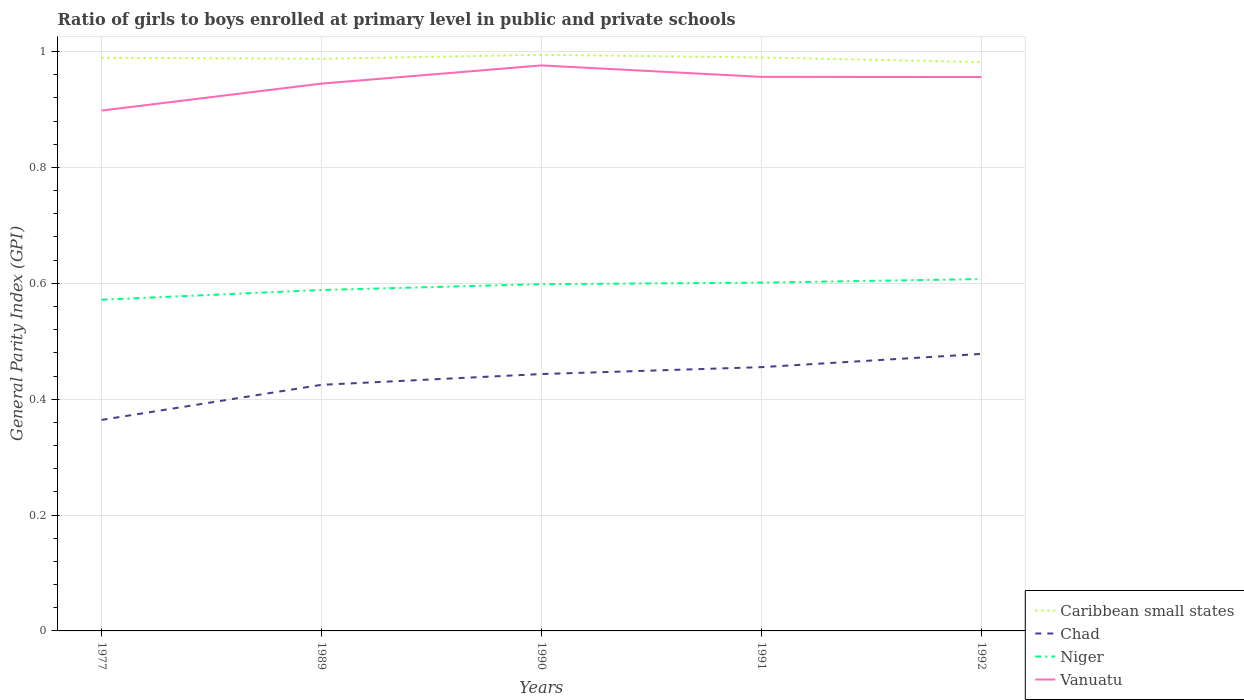Does the line corresponding to Niger intersect with the line corresponding to Chad?
Your answer should be compact. No. Across all years, what is the maximum general parity index in Caribbean small states?
Your answer should be very brief. 0.98. What is the total general parity index in Vanuatu in the graph?
Provide a short and direct response. -0.08. What is the difference between the highest and the second highest general parity index in Chad?
Provide a short and direct response. 0.11. What is the difference between the highest and the lowest general parity index in Chad?
Offer a terse response. 3. Is the general parity index in Niger strictly greater than the general parity index in Vanuatu over the years?
Offer a very short reply. Yes. How many years are there in the graph?
Make the answer very short. 5. Does the graph contain any zero values?
Make the answer very short. No. How many legend labels are there?
Your answer should be very brief. 4. How are the legend labels stacked?
Your response must be concise. Vertical. What is the title of the graph?
Your answer should be very brief. Ratio of girls to boys enrolled at primary level in public and private schools. Does "West Bank and Gaza" appear as one of the legend labels in the graph?
Keep it short and to the point. No. What is the label or title of the X-axis?
Your response must be concise. Years. What is the label or title of the Y-axis?
Your answer should be compact. General Parity Index (GPI). What is the General Parity Index (GPI) in Caribbean small states in 1977?
Your response must be concise. 0.99. What is the General Parity Index (GPI) of Chad in 1977?
Provide a succinct answer. 0.36. What is the General Parity Index (GPI) in Niger in 1977?
Your answer should be compact. 0.57. What is the General Parity Index (GPI) in Vanuatu in 1977?
Offer a very short reply. 0.9. What is the General Parity Index (GPI) of Caribbean small states in 1989?
Provide a short and direct response. 0.99. What is the General Parity Index (GPI) of Chad in 1989?
Your answer should be very brief. 0.42. What is the General Parity Index (GPI) of Niger in 1989?
Make the answer very short. 0.59. What is the General Parity Index (GPI) of Vanuatu in 1989?
Give a very brief answer. 0.94. What is the General Parity Index (GPI) of Caribbean small states in 1990?
Give a very brief answer. 0.99. What is the General Parity Index (GPI) in Chad in 1990?
Your answer should be compact. 0.44. What is the General Parity Index (GPI) in Niger in 1990?
Provide a short and direct response. 0.6. What is the General Parity Index (GPI) in Vanuatu in 1990?
Offer a very short reply. 0.98. What is the General Parity Index (GPI) of Caribbean small states in 1991?
Provide a short and direct response. 0.99. What is the General Parity Index (GPI) of Chad in 1991?
Give a very brief answer. 0.46. What is the General Parity Index (GPI) of Niger in 1991?
Provide a succinct answer. 0.6. What is the General Parity Index (GPI) of Vanuatu in 1991?
Provide a succinct answer. 0.96. What is the General Parity Index (GPI) in Caribbean small states in 1992?
Give a very brief answer. 0.98. What is the General Parity Index (GPI) of Chad in 1992?
Provide a succinct answer. 0.48. What is the General Parity Index (GPI) of Niger in 1992?
Provide a short and direct response. 0.61. What is the General Parity Index (GPI) in Vanuatu in 1992?
Ensure brevity in your answer.  0.96. Across all years, what is the maximum General Parity Index (GPI) in Caribbean small states?
Keep it short and to the point. 0.99. Across all years, what is the maximum General Parity Index (GPI) of Chad?
Give a very brief answer. 0.48. Across all years, what is the maximum General Parity Index (GPI) of Niger?
Your answer should be compact. 0.61. Across all years, what is the maximum General Parity Index (GPI) in Vanuatu?
Your answer should be very brief. 0.98. Across all years, what is the minimum General Parity Index (GPI) of Caribbean small states?
Offer a very short reply. 0.98. Across all years, what is the minimum General Parity Index (GPI) of Chad?
Offer a very short reply. 0.36. Across all years, what is the minimum General Parity Index (GPI) in Niger?
Provide a short and direct response. 0.57. Across all years, what is the minimum General Parity Index (GPI) of Vanuatu?
Give a very brief answer. 0.9. What is the total General Parity Index (GPI) in Caribbean small states in the graph?
Your answer should be very brief. 4.94. What is the total General Parity Index (GPI) in Chad in the graph?
Offer a very short reply. 2.17. What is the total General Parity Index (GPI) of Niger in the graph?
Provide a short and direct response. 2.97. What is the total General Parity Index (GPI) of Vanuatu in the graph?
Give a very brief answer. 4.73. What is the difference between the General Parity Index (GPI) in Caribbean small states in 1977 and that in 1989?
Ensure brevity in your answer.  0. What is the difference between the General Parity Index (GPI) in Chad in 1977 and that in 1989?
Give a very brief answer. -0.06. What is the difference between the General Parity Index (GPI) of Niger in 1977 and that in 1989?
Provide a short and direct response. -0.02. What is the difference between the General Parity Index (GPI) in Vanuatu in 1977 and that in 1989?
Ensure brevity in your answer.  -0.05. What is the difference between the General Parity Index (GPI) of Caribbean small states in 1977 and that in 1990?
Ensure brevity in your answer.  -0.01. What is the difference between the General Parity Index (GPI) in Chad in 1977 and that in 1990?
Your answer should be compact. -0.08. What is the difference between the General Parity Index (GPI) in Niger in 1977 and that in 1990?
Keep it short and to the point. -0.03. What is the difference between the General Parity Index (GPI) of Vanuatu in 1977 and that in 1990?
Make the answer very short. -0.08. What is the difference between the General Parity Index (GPI) in Caribbean small states in 1977 and that in 1991?
Keep it short and to the point. -0. What is the difference between the General Parity Index (GPI) in Chad in 1977 and that in 1991?
Provide a short and direct response. -0.09. What is the difference between the General Parity Index (GPI) of Niger in 1977 and that in 1991?
Offer a very short reply. -0.03. What is the difference between the General Parity Index (GPI) in Vanuatu in 1977 and that in 1991?
Offer a very short reply. -0.06. What is the difference between the General Parity Index (GPI) in Caribbean small states in 1977 and that in 1992?
Provide a short and direct response. 0.01. What is the difference between the General Parity Index (GPI) of Chad in 1977 and that in 1992?
Offer a terse response. -0.11. What is the difference between the General Parity Index (GPI) in Niger in 1977 and that in 1992?
Your response must be concise. -0.04. What is the difference between the General Parity Index (GPI) of Vanuatu in 1977 and that in 1992?
Make the answer very short. -0.06. What is the difference between the General Parity Index (GPI) of Caribbean small states in 1989 and that in 1990?
Make the answer very short. -0.01. What is the difference between the General Parity Index (GPI) of Chad in 1989 and that in 1990?
Provide a short and direct response. -0.02. What is the difference between the General Parity Index (GPI) of Niger in 1989 and that in 1990?
Provide a succinct answer. -0.01. What is the difference between the General Parity Index (GPI) in Vanuatu in 1989 and that in 1990?
Offer a terse response. -0.03. What is the difference between the General Parity Index (GPI) of Caribbean small states in 1989 and that in 1991?
Offer a very short reply. -0. What is the difference between the General Parity Index (GPI) of Chad in 1989 and that in 1991?
Give a very brief answer. -0.03. What is the difference between the General Parity Index (GPI) of Niger in 1989 and that in 1991?
Offer a very short reply. -0.01. What is the difference between the General Parity Index (GPI) of Vanuatu in 1989 and that in 1991?
Keep it short and to the point. -0.01. What is the difference between the General Parity Index (GPI) in Caribbean small states in 1989 and that in 1992?
Your answer should be compact. 0.01. What is the difference between the General Parity Index (GPI) of Chad in 1989 and that in 1992?
Offer a very short reply. -0.05. What is the difference between the General Parity Index (GPI) in Niger in 1989 and that in 1992?
Give a very brief answer. -0.02. What is the difference between the General Parity Index (GPI) in Vanuatu in 1989 and that in 1992?
Your response must be concise. -0.01. What is the difference between the General Parity Index (GPI) of Caribbean small states in 1990 and that in 1991?
Give a very brief answer. 0. What is the difference between the General Parity Index (GPI) of Chad in 1990 and that in 1991?
Provide a short and direct response. -0.01. What is the difference between the General Parity Index (GPI) of Niger in 1990 and that in 1991?
Offer a very short reply. -0. What is the difference between the General Parity Index (GPI) in Vanuatu in 1990 and that in 1991?
Ensure brevity in your answer.  0.02. What is the difference between the General Parity Index (GPI) of Caribbean small states in 1990 and that in 1992?
Offer a terse response. 0.01. What is the difference between the General Parity Index (GPI) of Chad in 1990 and that in 1992?
Make the answer very short. -0.03. What is the difference between the General Parity Index (GPI) in Niger in 1990 and that in 1992?
Make the answer very short. -0.01. What is the difference between the General Parity Index (GPI) of Vanuatu in 1990 and that in 1992?
Offer a very short reply. 0.02. What is the difference between the General Parity Index (GPI) in Caribbean small states in 1991 and that in 1992?
Your response must be concise. 0.01. What is the difference between the General Parity Index (GPI) in Chad in 1991 and that in 1992?
Give a very brief answer. -0.02. What is the difference between the General Parity Index (GPI) of Niger in 1991 and that in 1992?
Offer a very short reply. -0.01. What is the difference between the General Parity Index (GPI) of Caribbean small states in 1977 and the General Parity Index (GPI) of Chad in 1989?
Give a very brief answer. 0.56. What is the difference between the General Parity Index (GPI) in Caribbean small states in 1977 and the General Parity Index (GPI) in Niger in 1989?
Offer a very short reply. 0.4. What is the difference between the General Parity Index (GPI) of Caribbean small states in 1977 and the General Parity Index (GPI) of Vanuatu in 1989?
Your answer should be very brief. 0.04. What is the difference between the General Parity Index (GPI) in Chad in 1977 and the General Parity Index (GPI) in Niger in 1989?
Ensure brevity in your answer.  -0.22. What is the difference between the General Parity Index (GPI) in Chad in 1977 and the General Parity Index (GPI) in Vanuatu in 1989?
Give a very brief answer. -0.58. What is the difference between the General Parity Index (GPI) in Niger in 1977 and the General Parity Index (GPI) in Vanuatu in 1989?
Offer a very short reply. -0.37. What is the difference between the General Parity Index (GPI) in Caribbean small states in 1977 and the General Parity Index (GPI) in Chad in 1990?
Ensure brevity in your answer.  0.55. What is the difference between the General Parity Index (GPI) in Caribbean small states in 1977 and the General Parity Index (GPI) in Niger in 1990?
Your answer should be compact. 0.39. What is the difference between the General Parity Index (GPI) in Caribbean small states in 1977 and the General Parity Index (GPI) in Vanuatu in 1990?
Your response must be concise. 0.01. What is the difference between the General Parity Index (GPI) in Chad in 1977 and the General Parity Index (GPI) in Niger in 1990?
Your answer should be compact. -0.23. What is the difference between the General Parity Index (GPI) of Chad in 1977 and the General Parity Index (GPI) of Vanuatu in 1990?
Your response must be concise. -0.61. What is the difference between the General Parity Index (GPI) in Niger in 1977 and the General Parity Index (GPI) in Vanuatu in 1990?
Your answer should be very brief. -0.4. What is the difference between the General Parity Index (GPI) of Caribbean small states in 1977 and the General Parity Index (GPI) of Chad in 1991?
Ensure brevity in your answer.  0.53. What is the difference between the General Parity Index (GPI) in Caribbean small states in 1977 and the General Parity Index (GPI) in Niger in 1991?
Keep it short and to the point. 0.39. What is the difference between the General Parity Index (GPI) in Caribbean small states in 1977 and the General Parity Index (GPI) in Vanuatu in 1991?
Offer a terse response. 0.03. What is the difference between the General Parity Index (GPI) in Chad in 1977 and the General Parity Index (GPI) in Niger in 1991?
Make the answer very short. -0.24. What is the difference between the General Parity Index (GPI) of Chad in 1977 and the General Parity Index (GPI) of Vanuatu in 1991?
Your response must be concise. -0.59. What is the difference between the General Parity Index (GPI) in Niger in 1977 and the General Parity Index (GPI) in Vanuatu in 1991?
Offer a terse response. -0.38. What is the difference between the General Parity Index (GPI) of Caribbean small states in 1977 and the General Parity Index (GPI) of Chad in 1992?
Offer a terse response. 0.51. What is the difference between the General Parity Index (GPI) in Caribbean small states in 1977 and the General Parity Index (GPI) in Niger in 1992?
Provide a succinct answer. 0.38. What is the difference between the General Parity Index (GPI) of Chad in 1977 and the General Parity Index (GPI) of Niger in 1992?
Provide a succinct answer. -0.24. What is the difference between the General Parity Index (GPI) in Chad in 1977 and the General Parity Index (GPI) in Vanuatu in 1992?
Offer a very short reply. -0.59. What is the difference between the General Parity Index (GPI) in Niger in 1977 and the General Parity Index (GPI) in Vanuatu in 1992?
Ensure brevity in your answer.  -0.38. What is the difference between the General Parity Index (GPI) of Caribbean small states in 1989 and the General Parity Index (GPI) of Chad in 1990?
Offer a very short reply. 0.54. What is the difference between the General Parity Index (GPI) in Caribbean small states in 1989 and the General Parity Index (GPI) in Niger in 1990?
Make the answer very short. 0.39. What is the difference between the General Parity Index (GPI) of Caribbean small states in 1989 and the General Parity Index (GPI) of Vanuatu in 1990?
Keep it short and to the point. 0.01. What is the difference between the General Parity Index (GPI) of Chad in 1989 and the General Parity Index (GPI) of Niger in 1990?
Offer a very short reply. -0.17. What is the difference between the General Parity Index (GPI) of Chad in 1989 and the General Parity Index (GPI) of Vanuatu in 1990?
Your response must be concise. -0.55. What is the difference between the General Parity Index (GPI) of Niger in 1989 and the General Parity Index (GPI) of Vanuatu in 1990?
Provide a succinct answer. -0.39. What is the difference between the General Parity Index (GPI) of Caribbean small states in 1989 and the General Parity Index (GPI) of Chad in 1991?
Provide a short and direct response. 0.53. What is the difference between the General Parity Index (GPI) in Caribbean small states in 1989 and the General Parity Index (GPI) in Niger in 1991?
Make the answer very short. 0.39. What is the difference between the General Parity Index (GPI) of Caribbean small states in 1989 and the General Parity Index (GPI) of Vanuatu in 1991?
Your answer should be compact. 0.03. What is the difference between the General Parity Index (GPI) in Chad in 1989 and the General Parity Index (GPI) in Niger in 1991?
Your response must be concise. -0.18. What is the difference between the General Parity Index (GPI) in Chad in 1989 and the General Parity Index (GPI) in Vanuatu in 1991?
Your response must be concise. -0.53. What is the difference between the General Parity Index (GPI) in Niger in 1989 and the General Parity Index (GPI) in Vanuatu in 1991?
Your answer should be very brief. -0.37. What is the difference between the General Parity Index (GPI) of Caribbean small states in 1989 and the General Parity Index (GPI) of Chad in 1992?
Your answer should be compact. 0.51. What is the difference between the General Parity Index (GPI) of Caribbean small states in 1989 and the General Parity Index (GPI) of Niger in 1992?
Your answer should be compact. 0.38. What is the difference between the General Parity Index (GPI) of Caribbean small states in 1989 and the General Parity Index (GPI) of Vanuatu in 1992?
Offer a terse response. 0.03. What is the difference between the General Parity Index (GPI) of Chad in 1989 and the General Parity Index (GPI) of Niger in 1992?
Provide a succinct answer. -0.18. What is the difference between the General Parity Index (GPI) of Chad in 1989 and the General Parity Index (GPI) of Vanuatu in 1992?
Keep it short and to the point. -0.53. What is the difference between the General Parity Index (GPI) in Niger in 1989 and the General Parity Index (GPI) in Vanuatu in 1992?
Give a very brief answer. -0.37. What is the difference between the General Parity Index (GPI) in Caribbean small states in 1990 and the General Parity Index (GPI) in Chad in 1991?
Your response must be concise. 0.54. What is the difference between the General Parity Index (GPI) in Caribbean small states in 1990 and the General Parity Index (GPI) in Niger in 1991?
Keep it short and to the point. 0.39. What is the difference between the General Parity Index (GPI) in Caribbean small states in 1990 and the General Parity Index (GPI) in Vanuatu in 1991?
Give a very brief answer. 0.04. What is the difference between the General Parity Index (GPI) of Chad in 1990 and the General Parity Index (GPI) of Niger in 1991?
Your answer should be compact. -0.16. What is the difference between the General Parity Index (GPI) in Chad in 1990 and the General Parity Index (GPI) in Vanuatu in 1991?
Provide a succinct answer. -0.51. What is the difference between the General Parity Index (GPI) of Niger in 1990 and the General Parity Index (GPI) of Vanuatu in 1991?
Make the answer very short. -0.36. What is the difference between the General Parity Index (GPI) in Caribbean small states in 1990 and the General Parity Index (GPI) in Chad in 1992?
Your answer should be very brief. 0.52. What is the difference between the General Parity Index (GPI) in Caribbean small states in 1990 and the General Parity Index (GPI) in Niger in 1992?
Offer a terse response. 0.39. What is the difference between the General Parity Index (GPI) in Caribbean small states in 1990 and the General Parity Index (GPI) in Vanuatu in 1992?
Keep it short and to the point. 0.04. What is the difference between the General Parity Index (GPI) in Chad in 1990 and the General Parity Index (GPI) in Niger in 1992?
Offer a very short reply. -0.16. What is the difference between the General Parity Index (GPI) in Chad in 1990 and the General Parity Index (GPI) in Vanuatu in 1992?
Your response must be concise. -0.51. What is the difference between the General Parity Index (GPI) in Niger in 1990 and the General Parity Index (GPI) in Vanuatu in 1992?
Provide a succinct answer. -0.36. What is the difference between the General Parity Index (GPI) of Caribbean small states in 1991 and the General Parity Index (GPI) of Chad in 1992?
Provide a short and direct response. 0.51. What is the difference between the General Parity Index (GPI) in Caribbean small states in 1991 and the General Parity Index (GPI) in Niger in 1992?
Your response must be concise. 0.38. What is the difference between the General Parity Index (GPI) of Caribbean small states in 1991 and the General Parity Index (GPI) of Vanuatu in 1992?
Your answer should be compact. 0.03. What is the difference between the General Parity Index (GPI) of Chad in 1991 and the General Parity Index (GPI) of Niger in 1992?
Your response must be concise. -0.15. What is the difference between the General Parity Index (GPI) in Chad in 1991 and the General Parity Index (GPI) in Vanuatu in 1992?
Provide a short and direct response. -0.5. What is the difference between the General Parity Index (GPI) of Niger in 1991 and the General Parity Index (GPI) of Vanuatu in 1992?
Ensure brevity in your answer.  -0.35. What is the average General Parity Index (GPI) of Caribbean small states per year?
Your answer should be very brief. 0.99. What is the average General Parity Index (GPI) of Chad per year?
Provide a short and direct response. 0.43. What is the average General Parity Index (GPI) in Niger per year?
Your answer should be compact. 0.59. What is the average General Parity Index (GPI) of Vanuatu per year?
Offer a terse response. 0.95. In the year 1977, what is the difference between the General Parity Index (GPI) in Caribbean small states and General Parity Index (GPI) in Chad?
Make the answer very short. 0.63. In the year 1977, what is the difference between the General Parity Index (GPI) in Caribbean small states and General Parity Index (GPI) in Niger?
Offer a very short reply. 0.42. In the year 1977, what is the difference between the General Parity Index (GPI) of Caribbean small states and General Parity Index (GPI) of Vanuatu?
Keep it short and to the point. 0.09. In the year 1977, what is the difference between the General Parity Index (GPI) of Chad and General Parity Index (GPI) of Niger?
Provide a succinct answer. -0.21. In the year 1977, what is the difference between the General Parity Index (GPI) in Chad and General Parity Index (GPI) in Vanuatu?
Keep it short and to the point. -0.53. In the year 1977, what is the difference between the General Parity Index (GPI) in Niger and General Parity Index (GPI) in Vanuatu?
Offer a very short reply. -0.33. In the year 1989, what is the difference between the General Parity Index (GPI) in Caribbean small states and General Parity Index (GPI) in Chad?
Ensure brevity in your answer.  0.56. In the year 1989, what is the difference between the General Parity Index (GPI) of Caribbean small states and General Parity Index (GPI) of Niger?
Your response must be concise. 0.4. In the year 1989, what is the difference between the General Parity Index (GPI) of Caribbean small states and General Parity Index (GPI) of Vanuatu?
Your answer should be very brief. 0.04. In the year 1989, what is the difference between the General Parity Index (GPI) of Chad and General Parity Index (GPI) of Niger?
Ensure brevity in your answer.  -0.16. In the year 1989, what is the difference between the General Parity Index (GPI) of Chad and General Parity Index (GPI) of Vanuatu?
Your response must be concise. -0.52. In the year 1989, what is the difference between the General Parity Index (GPI) of Niger and General Parity Index (GPI) of Vanuatu?
Your answer should be very brief. -0.36. In the year 1990, what is the difference between the General Parity Index (GPI) of Caribbean small states and General Parity Index (GPI) of Chad?
Offer a terse response. 0.55. In the year 1990, what is the difference between the General Parity Index (GPI) in Caribbean small states and General Parity Index (GPI) in Niger?
Provide a succinct answer. 0.4. In the year 1990, what is the difference between the General Parity Index (GPI) of Caribbean small states and General Parity Index (GPI) of Vanuatu?
Your response must be concise. 0.02. In the year 1990, what is the difference between the General Parity Index (GPI) in Chad and General Parity Index (GPI) in Niger?
Provide a short and direct response. -0.16. In the year 1990, what is the difference between the General Parity Index (GPI) of Chad and General Parity Index (GPI) of Vanuatu?
Ensure brevity in your answer.  -0.53. In the year 1990, what is the difference between the General Parity Index (GPI) in Niger and General Parity Index (GPI) in Vanuatu?
Keep it short and to the point. -0.38. In the year 1991, what is the difference between the General Parity Index (GPI) in Caribbean small states and General Parity Index (GPI) in Chad?
Give a very brief answer. 0.53. In the year 1991, what is the difference between the General Parity Index (GPI) in Caribbean small states and General Parity Index (GPI) in Niger?
Give a very brief answer. 0.39. In the year 1991, what is the difference between the General Parity Index (GPI) of Caribbean small states and General Parity Index (GPI) of Vanuatu?
Your answer should be very brief. 0.03. In the year 1991, what is the difference between the General Parity Index (GPI) in Chad and General Parity Index (GPI) in Niger?
Make the answer very short. -0.15. In the year 1991, what is the difference between the General Parity Index (GPI) in Chad and General Parity Index (GPI) in Vanuatu?
Your response must be concise. -0.5. In the year 1991, what is the difference between the General Parity Index (GPI) of Niger and General Parity Index (GPI) of Vanuatu?
Ensure brevity in your answer.  -0.36. In the year 1992, what is the difference between the General Parity Index (GPI) of Caribbean small states and General Parity Index (GPI) of Chad?
Offer a very short reply. 0.5. In the year 1992, what is the difference between the General Parity Index (GPI) of Caribbean small states and General Parity Index (GPI) of Niger?
Your answer should be compact. 0.37. In the year 1992, what is the difference between the General Parity Index (GPI) of Caribbean small states and General Parity Index (GPI) of Vanuatu?
Make the answer very short. 0.03. In the year 1992, what is the difference between the General Parity Index (GPI) in Chad and General Parity Index (GPI) in Niger?
Provide a short and direct response. -0.13. In the year 1992, what is the difference between the General Parity Index (GPI) in Chad and General Parity Index (GPI) in Vanuatu?
Your response must be concise. -0.48. In the year 1992, what is the difference between the General Parity Index (GPI) in Niger and General Parity Index (GPI) in Vanuatu?
Your response must be concise. -0.35. What is the ratio of the General Parity Index (GPI) of Caribbean small states in 1977 to that in 1989?
Keep it short and to the point. 1. What is the ratio of the General Parity Index (GPI) in Chad in 1977 to that in 1989?
Give a very brief answer. 0.86. What is the ratio of the General Parity Index (GPI) in Niger in 1977 to that in 1989?
Ensure brevity in your answer.  0.97. What is the ratio of the General Parity Index (GPI) in Vanuatu in 1977 to that in 1989?
Your answer should be very brief. 0.95. What is the ratio of the General Parity Index (GPI) in Chad in 1977 to that in 1990?
Give a very brief answer. 0.82. What is the ratio of the General Parity Index (GPI) in Niger in 1977 to that in 1990?
Provide a succinct answer. 0.96. What is the ratio of the General Parity Index (GPI) of Vanuatu in 1977 to that in 1990?
Ensure brevity in your answer.  0.92. What is the ratio of the General Parity Index (GPI) in Niger in 1977 to that in 1991?
Give a very brief answer. 0.95. What is the ratio of the General Parity Index (GPI) of Vanuatu in 1977 to that in 1991?
Your answer should be compact. 0.94. What is the ratio of the General Parity Index (GPI) of Caribbean small states in 1977 to that in 1992?
Ensure brevity in your answer.  1.01. What is the ratio of the General Parity Index (GPI) in Chad in 1977 to that in 1992?
Give a very brief answer. 0.76. What is the ratio of the General Parity Index (GPI) of Niger in 1977 to that in 1992?
Ensure brevity in your answer.  0.94. What is the ratio of the General Parity Index (GPI) of Vanuatu in 1977 to that in 1992?
Offer a terse response. 0.94. What is the ratio of the General Parity Index (GPI) of Caribbean small states in 1989 to that in 1990?
Provide a succinct answer. 0.99. What is the ratio of the General Parity Index (GPI) in Chad in 1989 to that in 1990?
Your response must be concise. 0.96. What is the ratio of the General Parity Index (GPI) in Niger in 1989 to that in 1990?
Provide a succinct answer. 0.98. What is the ratio of the General Parity Index (GPI) in Vanuatu in 1989 to that in 1990?
Provide a succinct answer. 0.97. What is the ratio of the General Parity Index (GPI) of Chad in 1989 to that in 1991?
Your answer should be compact. 0.93. What is the ratio of the General Parity Index (GPI) in Niger in 1989 to that in 1991?
Your answer should be very brief. 0.98. What is the ratio of the General Parity Index (GPI) of Vanuatu in 1989 to that in 1991?
Offer a very short reply. 0.99. What is the ratio of the General Parity Index (GPI) in Caribbean small states in 1989 to that in 1992?
Give a very brief answer. 1.01. What is the ratio of the General Parity Index (GPI) of Chad in 1989 to that in 1992?
Offer a terse response. 0.89. What is the ratio of the General Parity Index (GPI) in Chad in 1990 to that in 1991?
Offer a terse response. 0.97. What is the ratio of the General Parity Index (GPI) in Vanuatu in 1990 to that in 1991?
Your answer should be very brief. 1.02. What is the ratio of the General Parity Index (GPI) in Caribbean small states in 1990 to that in 1992?
Make the answer very short. 1.01. What is the ratio of the General Parity Index (GPI) of Chad in 1990 to that in 1992?
Give a very brief answer. 0.93. What is the ratio of the General Parity Index (GPI) in Niger in 1990 to that in 1992?
Your answer should be compact. 0.99. What is the ratio of the General Parity Index (GPI) of Vanuatu in 1990 to that in 1992?
Keep it short and to the point. 1.02. What is the ratio of the General Parity Index (GPI) of Caribbean small states in 1991 to that in 1992?
Provide a succinct answer. 1.01. What is the ratio of the General Parity Index (GPI) in Chad in 1991 to that in 1992?
Keep it short and to the point. 0.95. What is the difference between the highest and the second highest General Parity Index (GPI) of Caribbean small states?
Offer a very short reply. 0. What is the difference between the highest and the second highest General Parity Index (GPI) of Chad?
Provide a short and direct response. 0.02. What is the difference between the highest and the second highest General Parity Index (GPI) in Niger?
Ensure brevity in your answer.  0.01. What is the difference between the highest and the second highest General Parity Index (GPI) in Vanuatu?
Offer a terse response. 0.02. What is the difference between the highest and the lowest General Parity Index (GPI) in Caribbean small states?
Your response must be concise. 0.01. What is the difference between the highest and the lowest General Parity Index (GPI) of Chad?
Provide a succinct answer. 0.11. What is the difference between the highest and the lowest General Parity Index (GPI) in Niger?
Keep it short and to the point. 0.04. What is the difference between the highest and the lowest General Parity Index (GPI) in Vanuatu?
Ensure brevity in your answer.  0.08. 